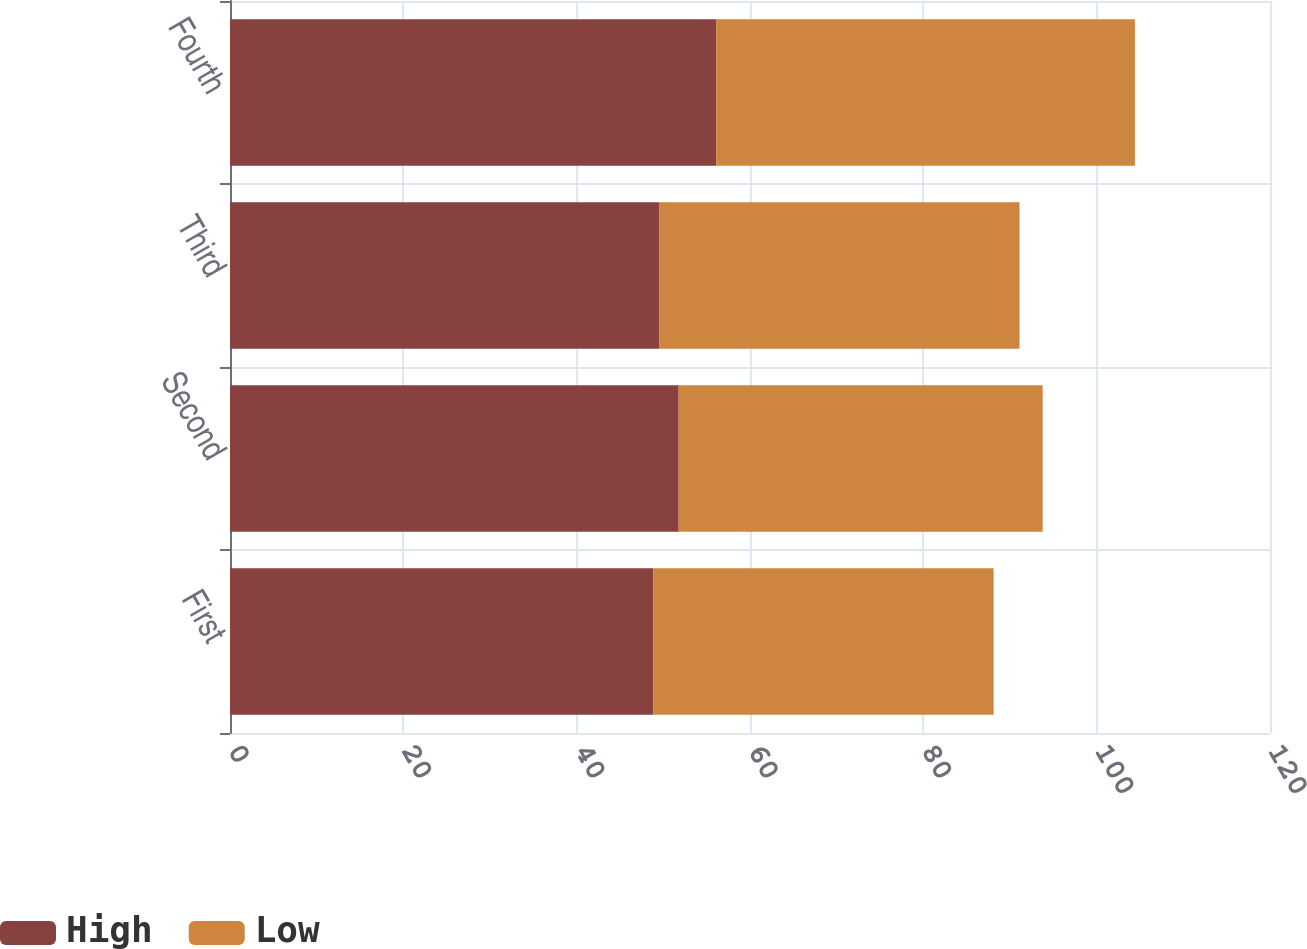Convert chart. <chart><loc_0><loc_0><loc_500><loc_500><stacked_bar_chart><ecel><fcel>First<fcel>Second<fcel>Third<fcel>Fourth<nl><fcel>High<fcel>48.83<fcel>51.77<fcel>49.51<fcel>56.1<nl><fcel>Low<fcel>39.28<fcel>42<fcel>41.59<fcel>48.31<nl></chart> 